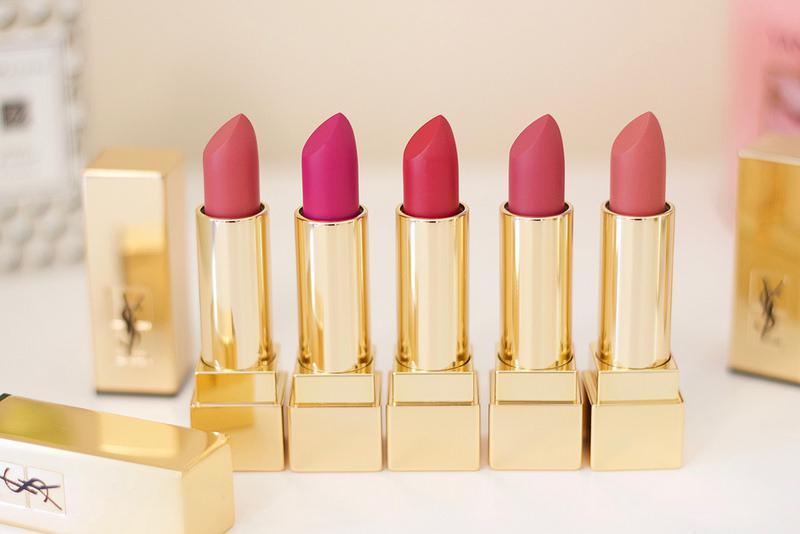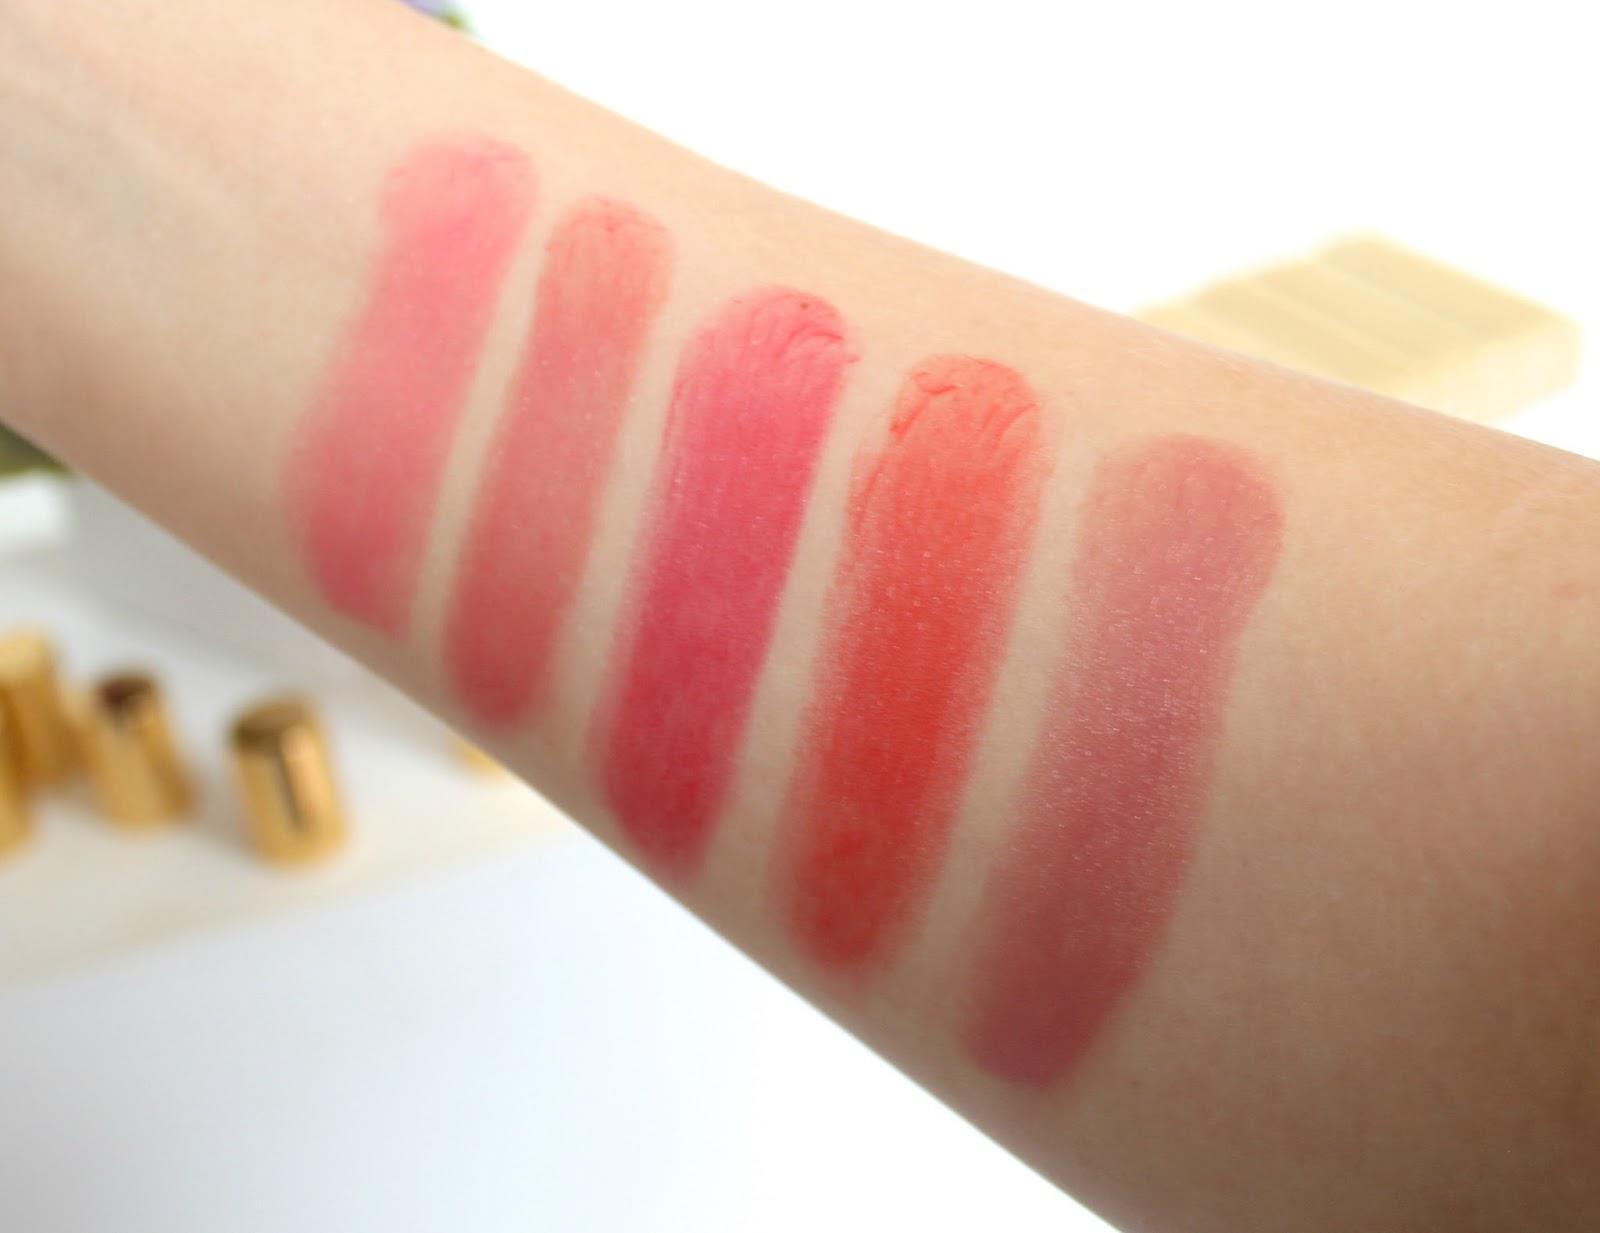The first image is the image on the left, the second image is the image on the right. For the images shown, is this caption "The right image contains a human arm with several different shades of lipstick drawn on it." true? Answer yes or no. Yes. The first image is the image on the left, the second image is the image on the right. Given the left and right images, does the statement "One image features a row of five uncapped tube lipsticks, and the other image shows an inner arm with five lipstick marks." hold true? Answer yes or no. Yes. 